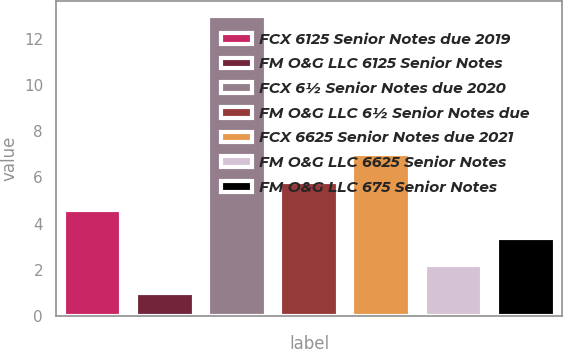<chart> <loc_0><loc_0><loc_500><loc_500><bar_chart><fcel>FCX 6125 Senior Notes due 2019<fcel>FM O&G LLC 6125 Senior Notes<fcel>FCX 6½ Senior Notes due 2020<fcel>FM O&G LLC 6½ Senior Notes due<fcel>FCX 6625 Senior Notes due 2021<fcel>FM O&G LLC 6625 Senior Notes<fcel>FM O&G LLC 675 Senior Notes<nl><fcel>4.6<fcel>1<fcel>13<fcel>5.8<fcel>7<fcel>2.2<fcel>3.4<nl></chart> 